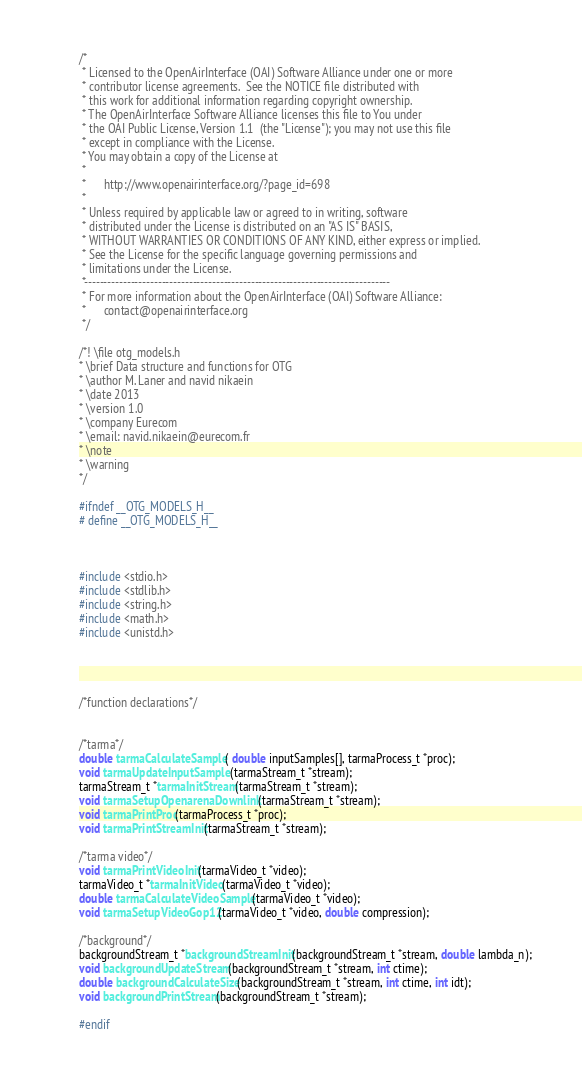<code> <loc_0><loc_0><loc_500><loc_500><_C_>/*
 * Licensed to the OpenAirInterface (OAI) Software Alliance under one or more
 * contributor license agreements.  See the NOTICE file distributed with
 * this work for additional information regarding copyright ownership.
 * The OpenAirInterface Software Alliance licenses this file to You under
 * the OAI Public License, Version 1.1  (the "License"); you may not use this file
 * except in compliance with the License.
 * You may obtain a copy of the License at
 *
 *      http://www.openairinterface.org/?page_id=698
 *
 * Unless required by applicable law or agreed to in writing, software
 * distributed under the License is distributed on an "AS IS" BASIS,
 * WITHOUT WARRANTIES OR CONDITIONS OF ANY KIND, either express or implied.
 * See the License for the specific language governing permissions and
 * limitations under the License.
 *-------------------------------------------------------------------------------
 * For more information about the OpenAirInterface (OAI) Software Alliance:
 *      contact@openairinterface.org
 */

/*! \file otg_models.h
* \brief Data structure and functions for OTG
* \author M. Laner and navid nikaein
* \date 2013
* \version 1.0
* \company Eurecom
* \email: navid.nikaein@eurecom.fr
* \note
* \warning
*/

#ifndef __OTG_MODELS_H__
# define __OTG_MODELS_H__



#include <stdio.h>
#include <stdlib.h>
#include <string.h>
#include <math.h>
#include <unistd.h>




/*function declarations*/


/*tarma*/
double tarmaCalculateSample( double inputSamples[], tarmaProcess_t *proc);
void tarmaUpdateInputSample (tarmaStream_t *stream);
tarmaStream_t *tarmaInitStream(tarmaStream_t *stream);
void tarmaSetupOpenarenaDownlink(tarmaStream_t *stream);
void tarmaPrintProc(tarmaProcess_t *proc);
void tarmaPrintStreamInit(tarmaStream_t *stream);

/*tarma video*/
void tarmaPrintVideoInit(tarmaVideo_t *video);
tarmaVideo_t *tarmaInitVideo(tarmaVideo_t *video);
double tarmaCalculateVideoSample(tarmaVideo_t *video);
void tarmaSetupVideoGop12(tarmaVideo_t *video, double compression);

/*background*/
backgroundStream_t *backgroundStreamInit(backgroundStream_t *stream, double lambda_n);
void backgroundUpdateStream(backgroundStream_t *stream, int ctime);
double backgroundCalculateSize(backgroundStream_t *stream, int ctime, int idt);
void backgroundPrintStream(backgroundStream_t *stream);

#endif
</code> 